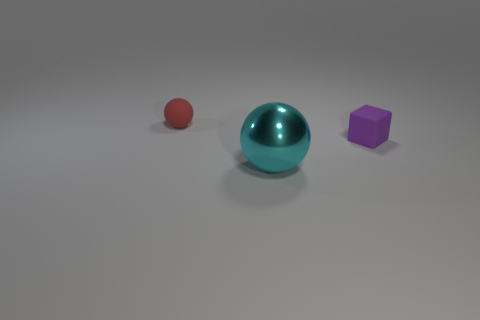Are there any other things that have the same shape as the large cyan thing? While the image displays a large cyan sphere alongside objects of different shapes and sizes, including a smaller sphere and a cube, they do not share the same shape. That said, the small red object is also a sphere, hence it shares the same geometric shape but differs in size and color. 